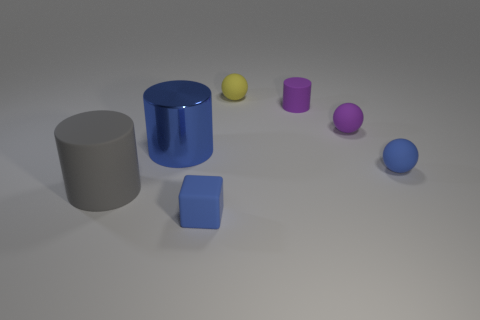Add 2 tiny blue blocks. How many objects exist? 9 Subtract all balls. How many objects are left? 4 Add 6 blue spheres. How many blue spheres exist? 7 Subtract 0 purple cubes. How many objects are left? 7 Subtract all small cyan metal objects. Subtract all blue spheres. How many objects are left? 6 Add 1 small yellow matte spheres. How many small yellow matte spheres are left? 2 